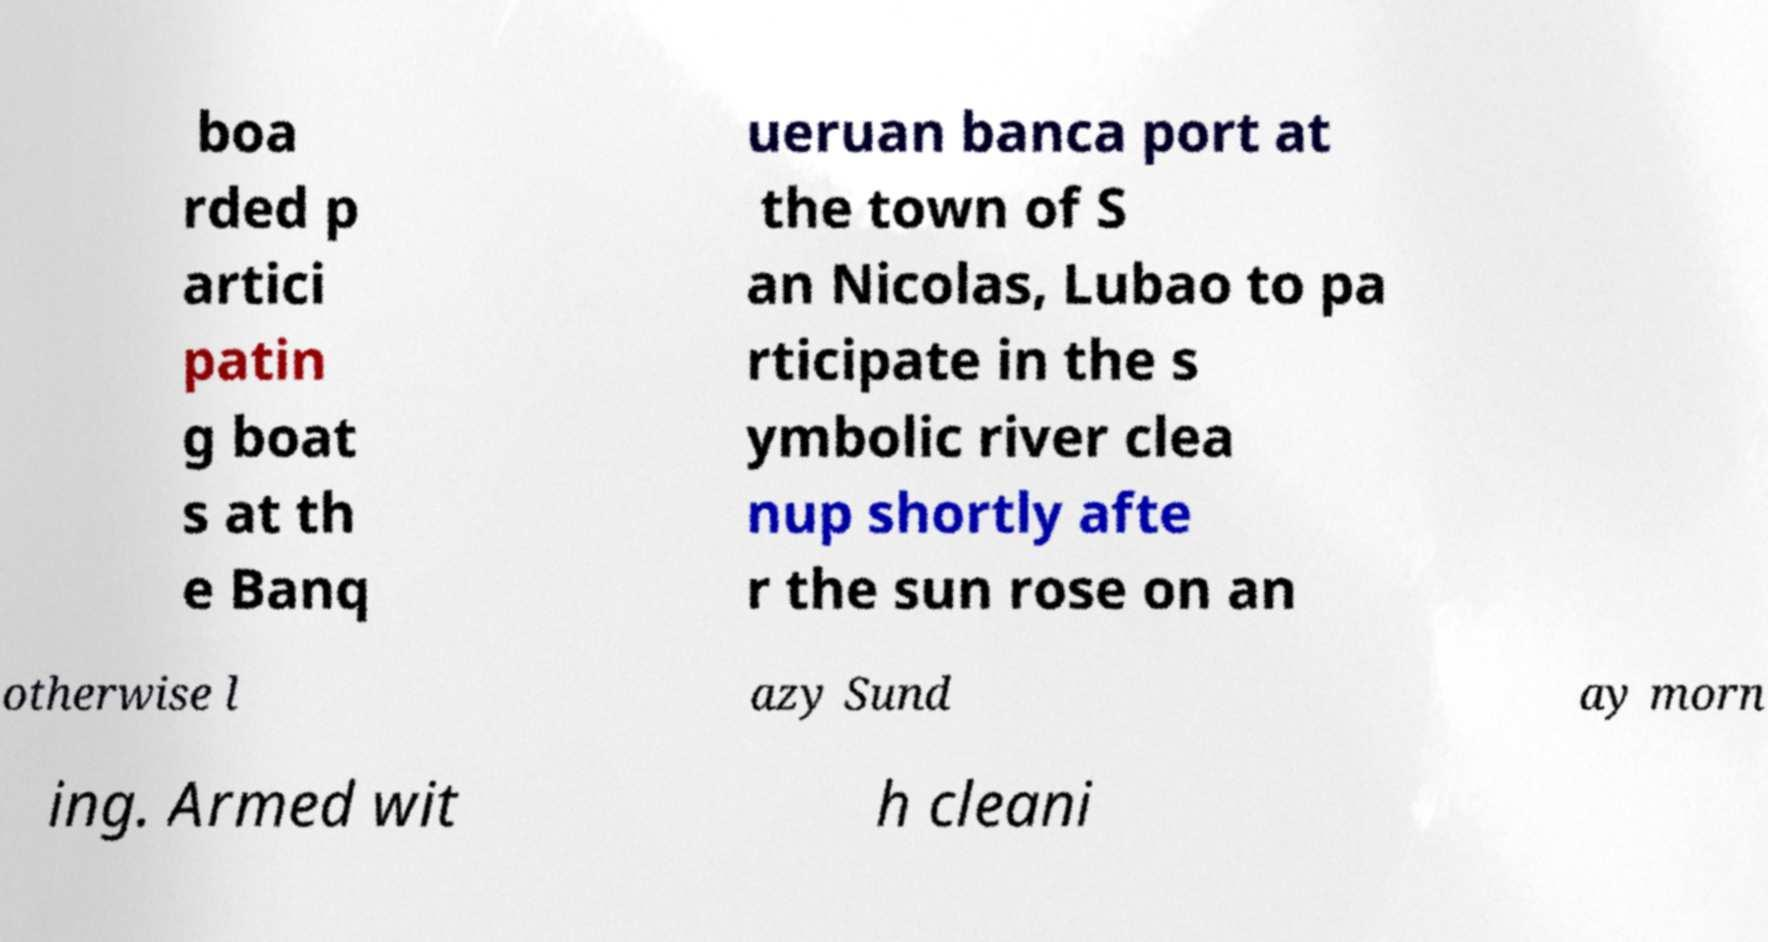For documentation purposes, I need the text within this image transcribed. Could you provide that? boa rded p artici patin g boat s at th e Banq ueruan banca port at the town of S an Nicolas, Lubao to pa rticipate in the s ymbolic river clea nup shortly afte r the sun rose on an otherwise l azy Sund ay morn ing. Armed wit h cleani 